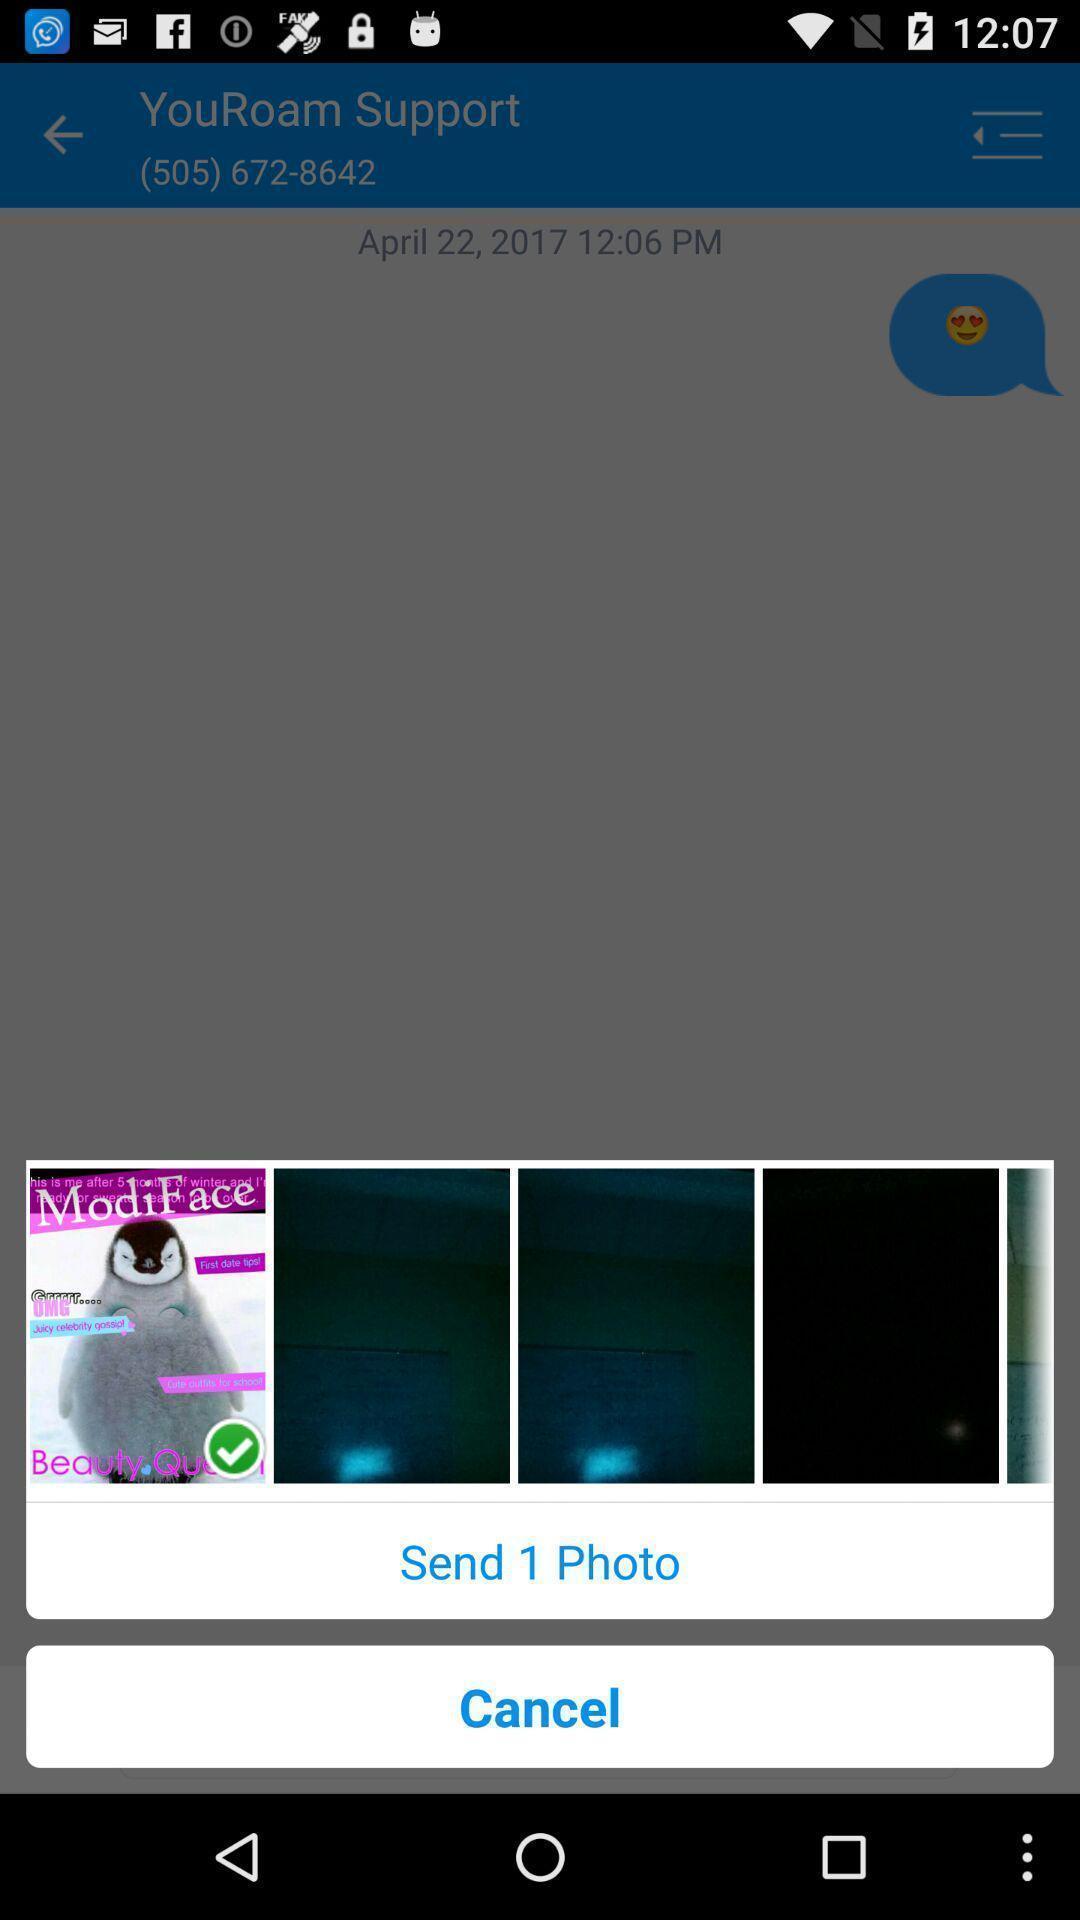Summarize the information in this screenshot. Sending feedback to the support executive. 